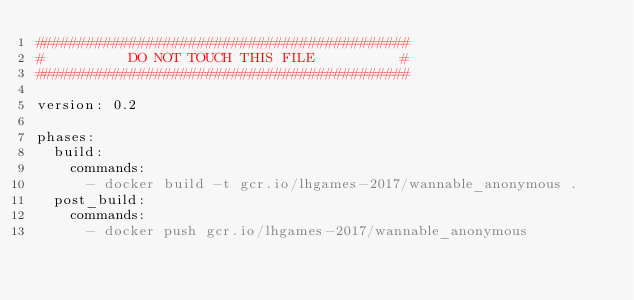Convert code to text. <code><loc_0><loc_0><loc_500><loc_500><_YAML_>############################################
#          DO NOT TOUCH THIS FILE          #
############################################

version: 0.2

phases:
  build:
    commands:
      - docker build -t gcr.io/lhgames-2017/wannable_anonymous .
  post_build:
    commands:
      - docker push gcr.io/lhgames-2017/wannable_anonymous
</code> 